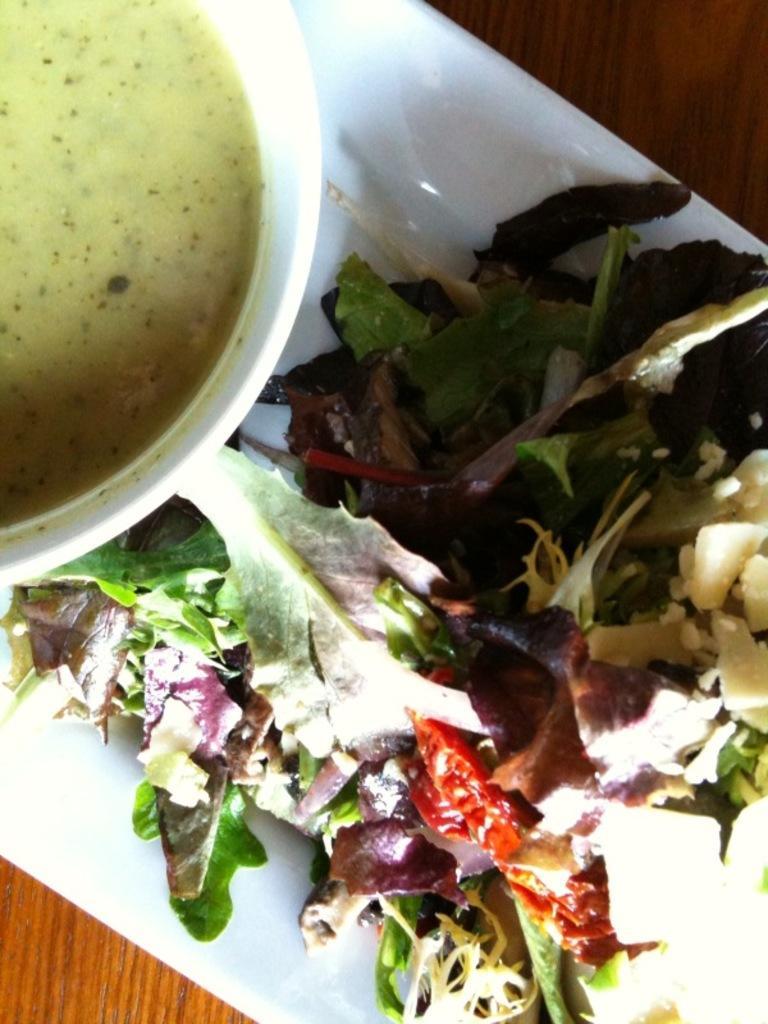Can you describe this image briefly? There is a white tray on a wooden surface. On that there is a bowl with food item and a salad with leaves and some other things. 